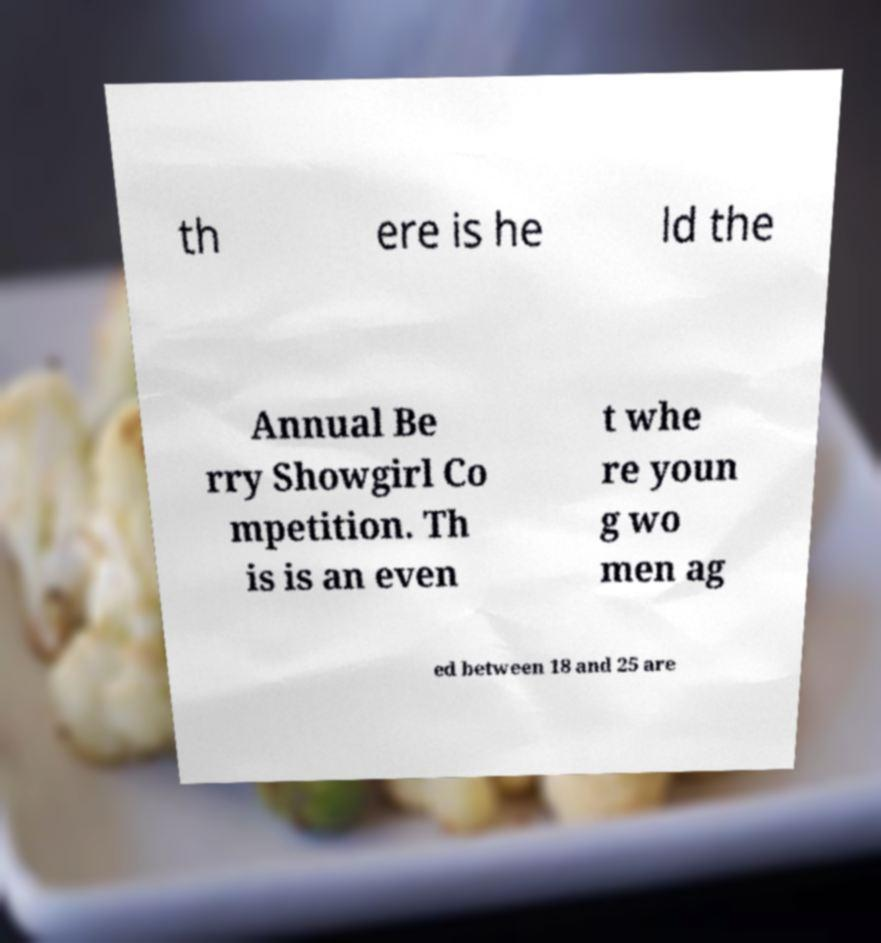Could you assist in decoding the text presented in this image and type it out clearly? th ere is he ld the Annual Be rry Showgirl Co mpetition. Th is is an even t whe re youn g wo men ag ed between 18 and 25 are 